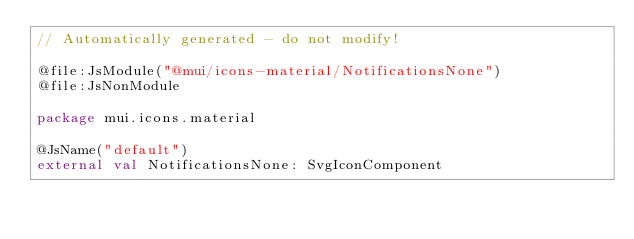<code> <loc_0><loc_0><loc_500><loc_500><_Kotlin_>// Automatically generated - do not modify!

@file:JsModule("@mui/icons-material/NotificationsNone")
@file:JsNonModule

package mui.icons.material

@JsName("default")
external val NotificationsNone: SvgIconComponent
</code> 